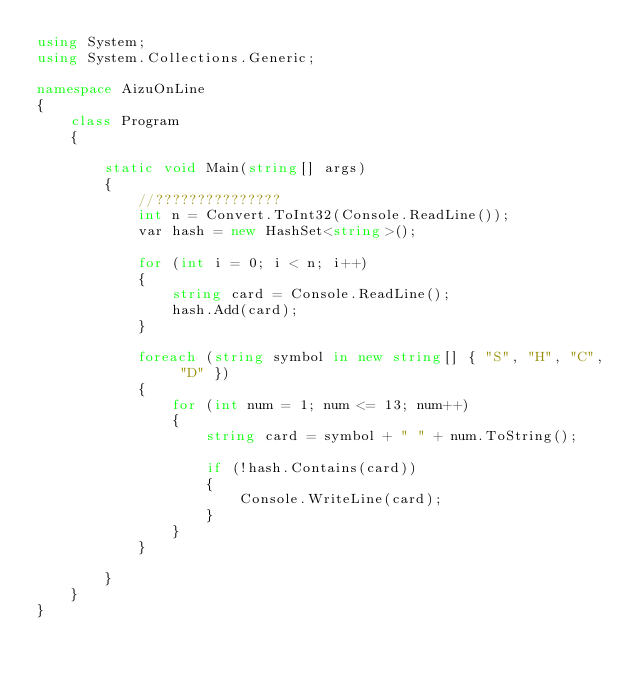Convert code to text. <code><loc_0><loc_0><loc_500><loc_500><_C#_>using System;
using System.Collections.Generic;
 
namespace AizuOnLine
{
    class Program
    {
 
        static void Main(string[] args)
        {
            //???????????????
            int n = Convert.ToInt32(Console.ReadLine());
            var hash = new HashSet<string>();
 
            for (int i = 0; i < n; i++)
            {
                string card = Console.ReadLine();
                hash.Add(card);
            }
 
            foreach (string symbol in new string[] { "S", "H", "C", "D" })
            {
                for (int num = 1; num <= 13; num++)
                {
                    string card = symbol + " " + num.ToString();
 
                    if (!hash.Contains(card))
                    {
                        Console.WriteLine(card);
                    }
                }
            }
 
        }
    }
}</code> 